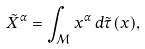<formula> <loc_0><loc_0><loc_500><loc_500>\tilde { X } ^ { \alpha } = \int _ { \mathcal { M } } x ^ { \alpha } \, d \tilde { \tau } ( x ) ,</formula> 